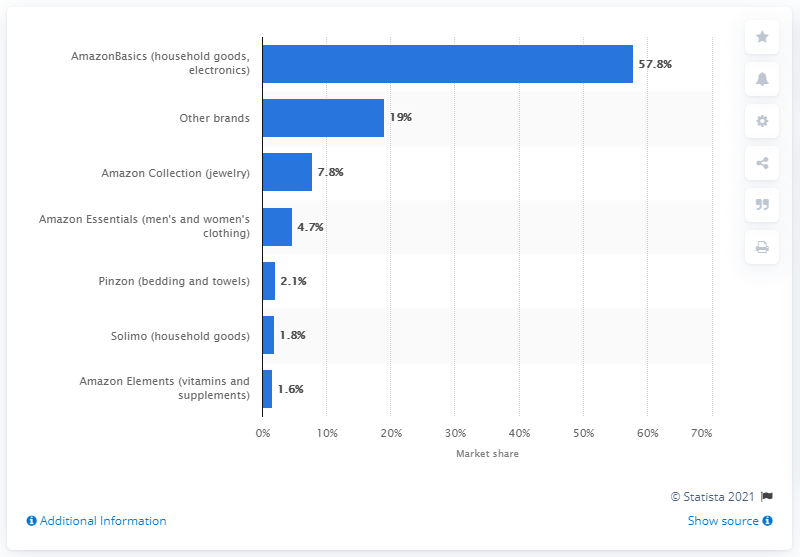Highlight a few significant elements in this photo. AmazonBasics accounted for 57.8% of Amazon's total sales in the given financial year. According to the information provided, Amazon Elements accounted for 1.6% of Amazon's total sales in 2022. 